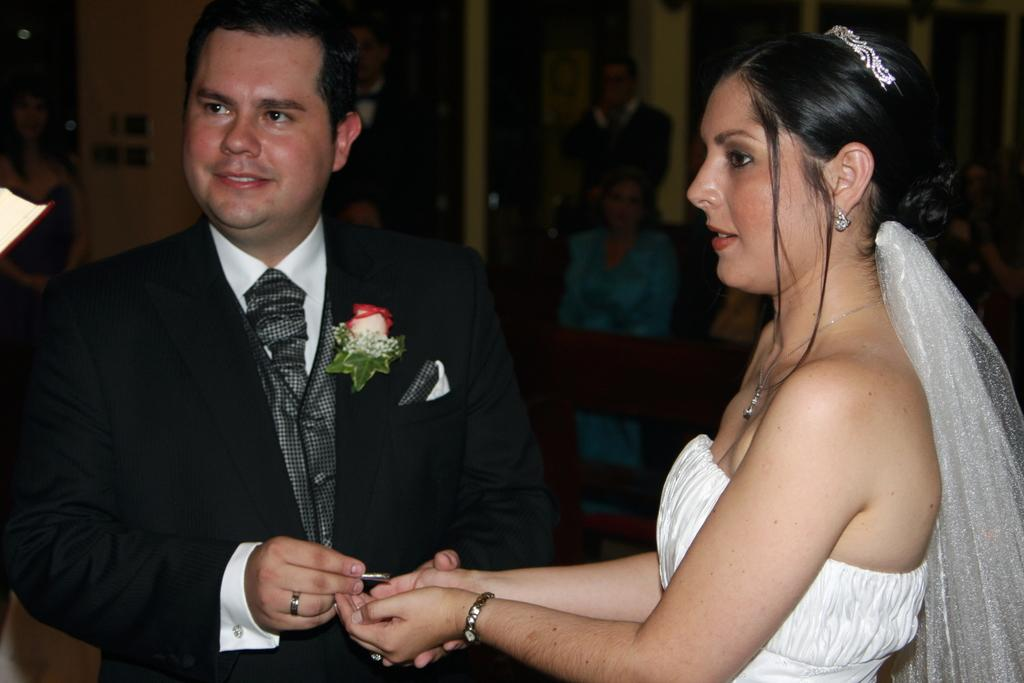How many people are present in the image? There are two people in the image. What are the two people doing in the image? The two people are holding an object. Can you describe the background of the image? There are other people visible in the background of the image. What type of lunchroom is visible in the image? There is no lunchroom present in the image. What connection can be made between the two people holding the object? The image does not provide information about any connection between the two people holding the object. 